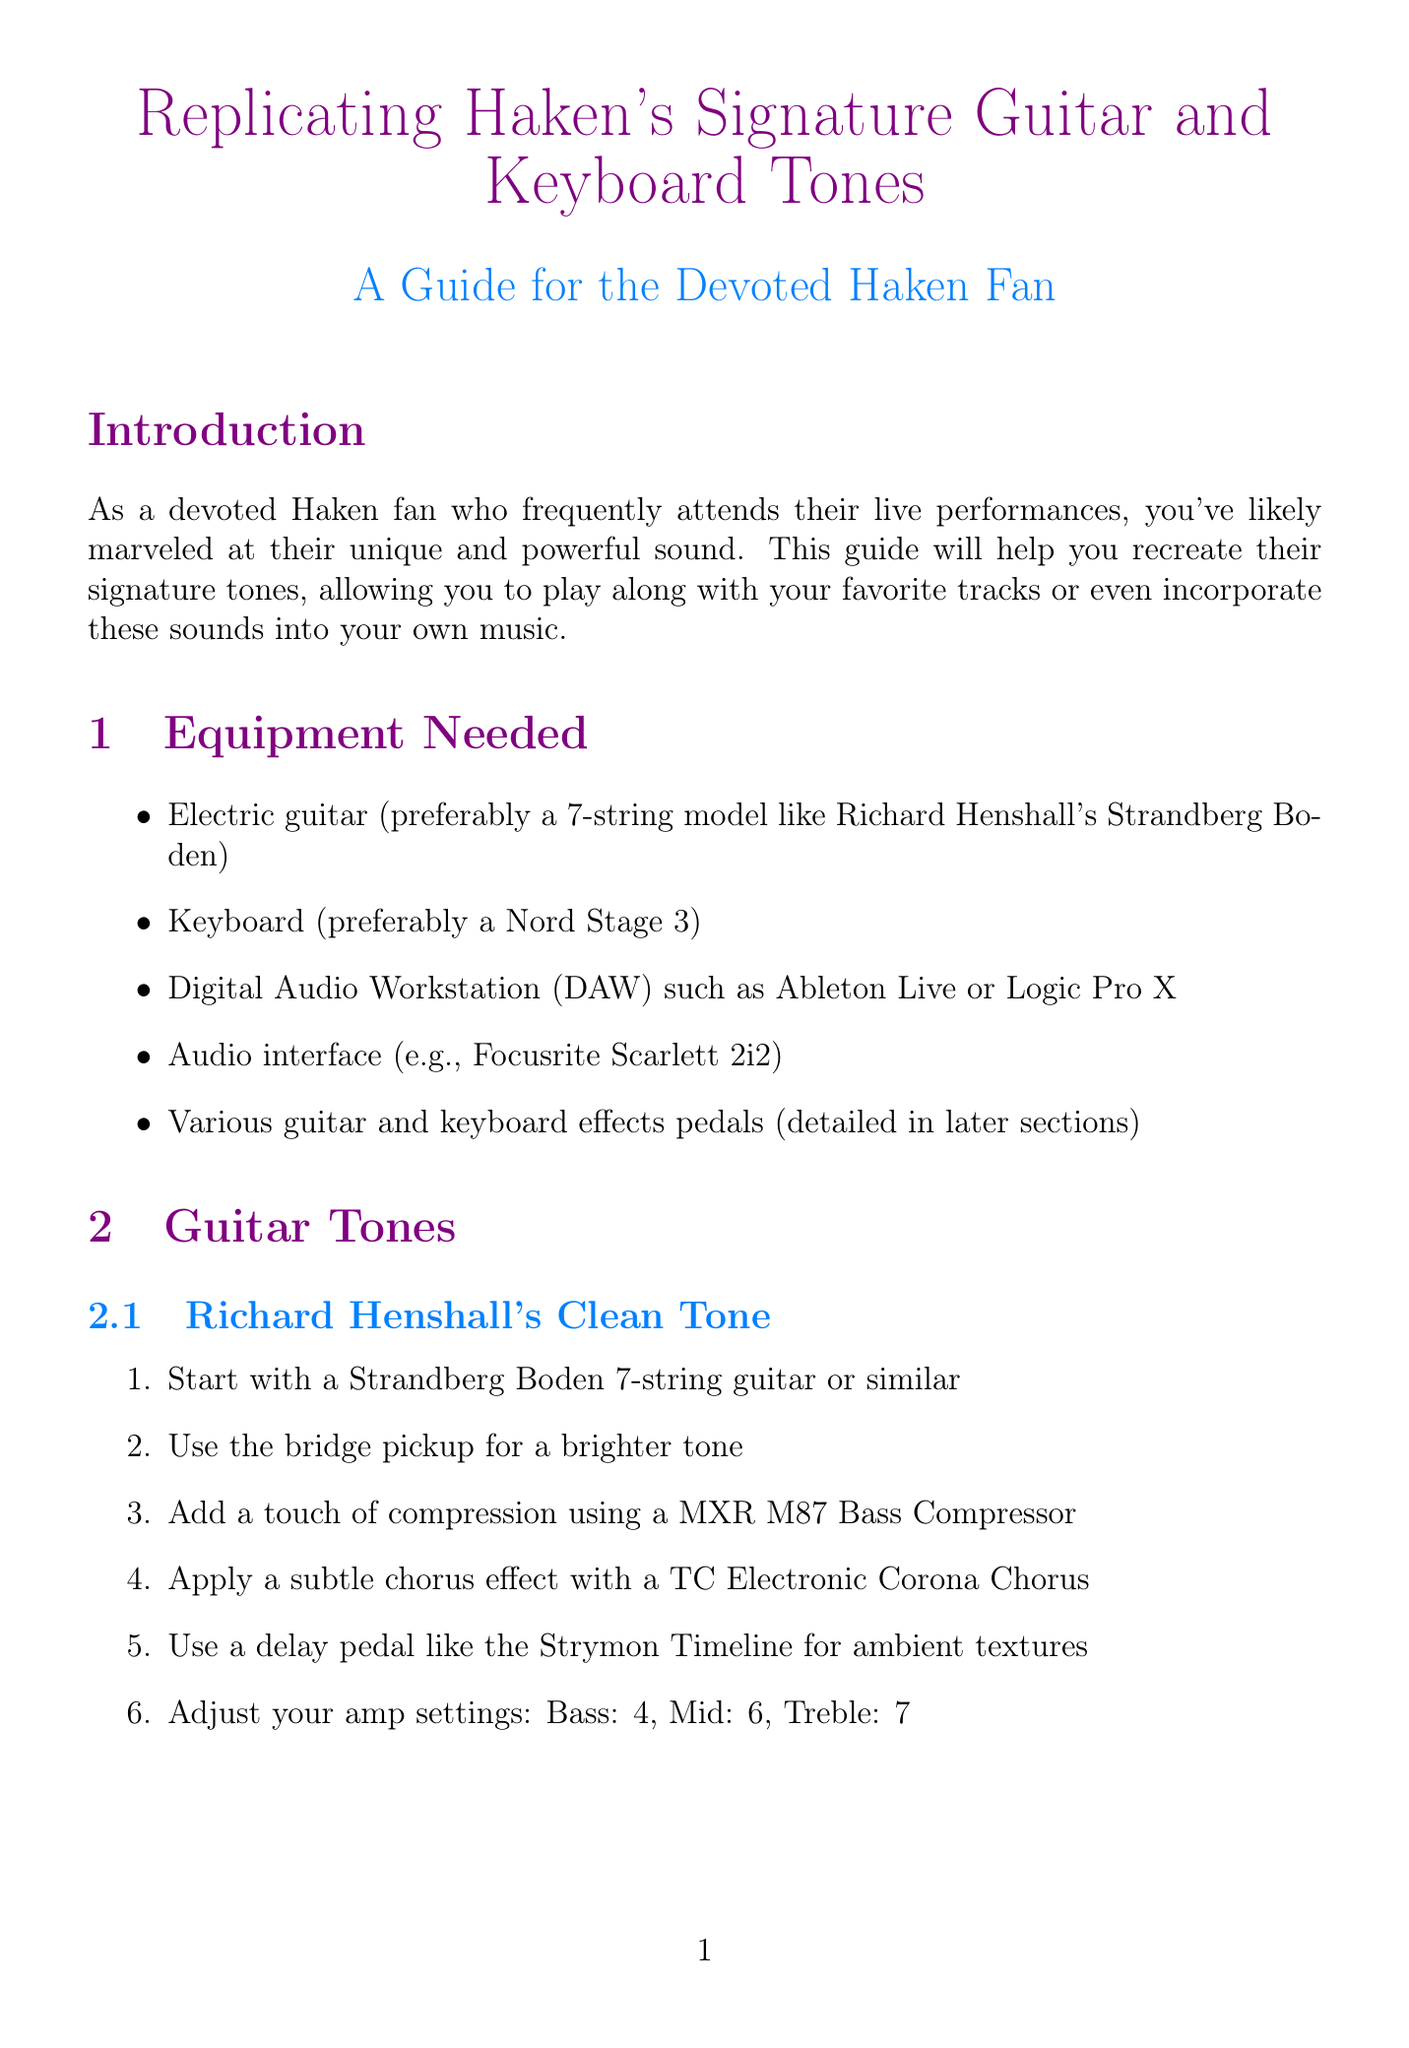what is the preferred guitar model for replicating Richard Henshall's clean tone? The document specifies starting with a Strandberg Boden 7-string guitar or similar for this tone.
Answer: Strandberg Boden 7-string what effects pedal is used for compression in Richard Henshall's clean tone? The guide mentions using a MXR M87 Bass Compressor for compression in this tone.
Answer: MXR M87 Bass Compressor what is the second oscillator wave type in Diego Tejeida's Synth Lead? The document instructs to add a second oscillator with a square wave for this synth lead.
Answer: square wave how many ambient pad sound layers are recommended? The guide suggests layering a soft pad from the 'Synth' section with a string ensemble sample for this sound.
Answer: two layers what is the recommended guitar amp setting for Charlie Griffiths' heavy rhythm tone on treble? The document states that the treble should be set to 6 in this tone.
Answer: 6 which plugin is recommended for creating complex synth sounds? The document highlights Native Instruments Massive as ideal for this purpose.
Answer: Native Instruments Massive what does the guide suggest for mastering Haken's intricate rhythms and melodies? The conclusion emphasizes the importance of practicing to master these aspects of Haken's music.
Answer: practicing what equipment is advised to use for the digital audio workstation? The document mentions using a DAW like Ableton Live or Logic Pro X.
Answer: Ableton Live or Logic Pro X what effect is suggested for enhancing spatiality in sounds? Valhalla VintageVerb is recommended for adding lush, spacious reverb to sounds.
Answer: Valhalla VintageVerb 